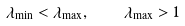<formula> <loc_0><loc_0><loc_500><loc_500>\lambda _ { \min } < \lambda _ { \max } , \quad \lambda _ { \max } > 1</formula> 